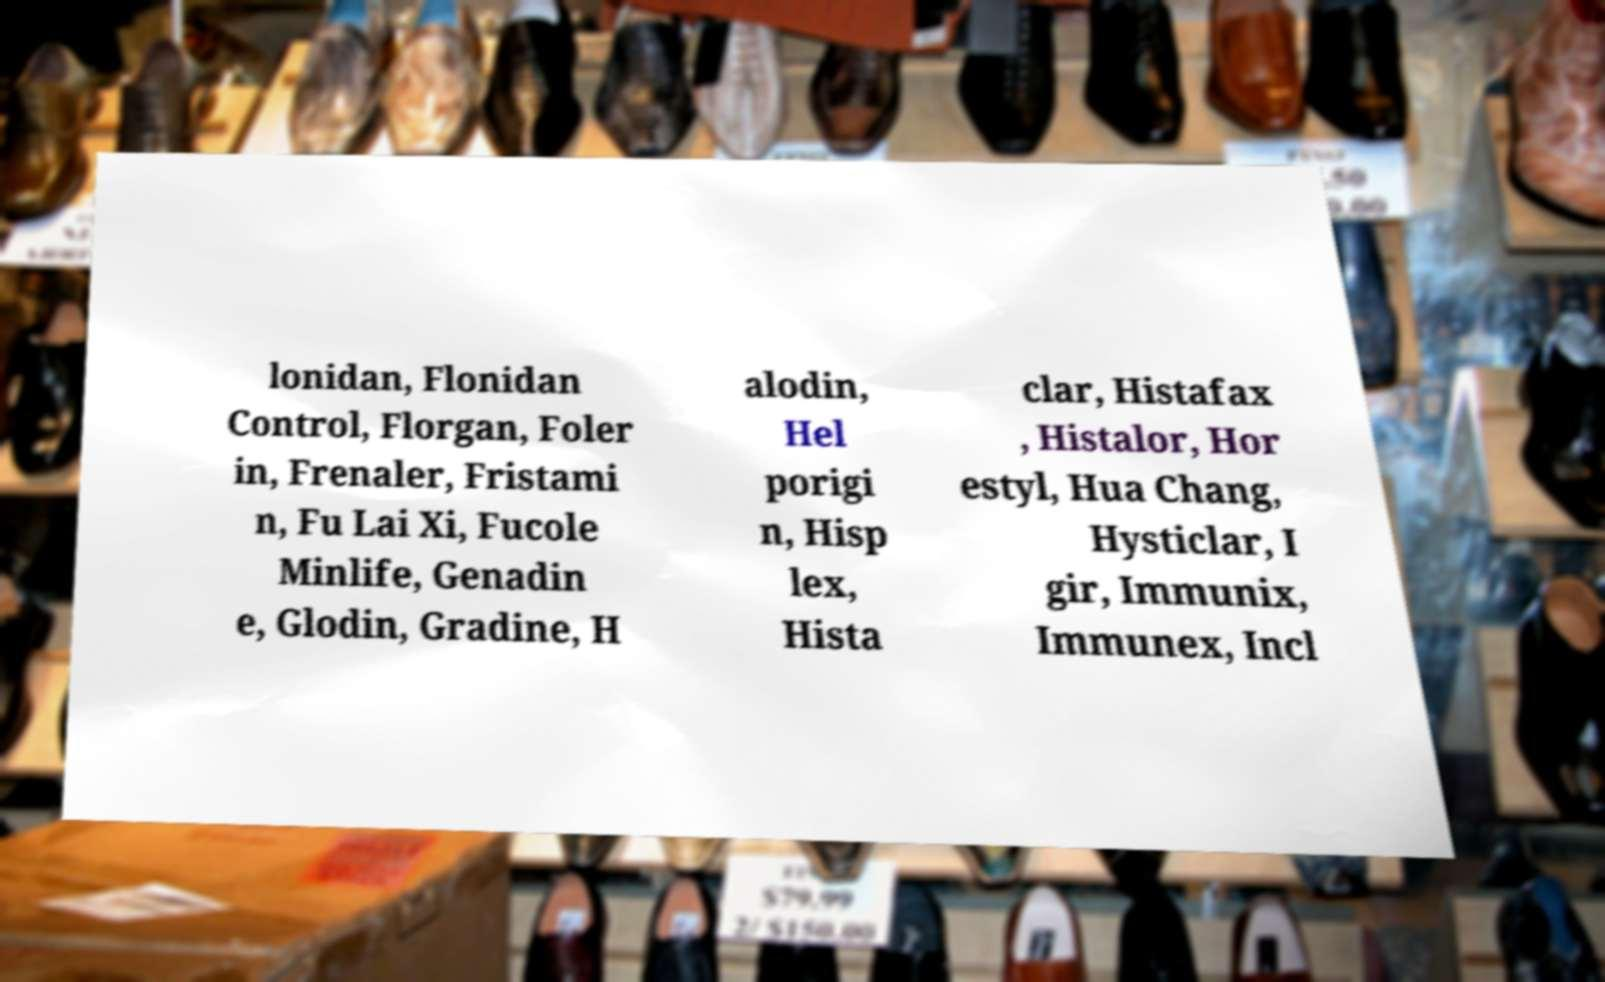Could you extract and type out the text from this image? lonidan, Flonidan Control, Florgan, Foler in, Frenaler, Fristami n, Fu Lai Xi, Fucole Minlife, Genadin e, Glodin, Gradine, H alodin, Hel porigi n, Hisp lex, Hista clar, Histafax , Histalor, Hor estyl, Hua Chang, Hysticlar, I gir, Immunix, Immunex, Incl 